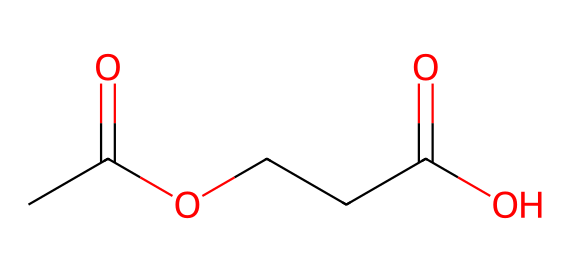What is the molecular formula indicated by the SMILES representation? The SMILES representation CC(=O)OCCC(=O)O can be interpreted as having two carboxylic acid groups (indicated by CC(=O)O) attached to a three-carbon chain (OCCC) which results in the molecular formula C5H8O4.
Answer: C5H8O4 How many carbon atoms are present in the structure? By examining the SMILES representation, there are two carbon atoms in the functional groups (CC(=O)O) and three in the middle chain (OCCC), making a total of five carbon atoms.
Answer: 5 What functional groups are present in this molecule? The chemical contains two carboxylic acid groups, as indicated by the appearance of -COOH in the structure (shown by CC(=O)O). Therefore, we conclude that carboxylic acid is the functional group present.
Answer: carboxylic acid What type of polymer can be produced from this chemical? The presence of multiple carboxylic acid functional groups suggests that this molecule can undergo polymerization reactions to form polyesters, which are common in synthetic fibers.
Answer: polyester What is the primary application of this chemical in textiles? Given that the structure represents a type of polyester, it is primarily used in making synthetic fibers for modern business attire due to its durability and wrinkle-resistant properties.
Answer: synthetic fibers How many hydroxyl groups are there in the molecule? In the given SMILES, each carboxylic acid contributes one hydroxyl (-OH) group to the structure; therefore, there are two hydroxyl groups present in total.
Answer: 2 